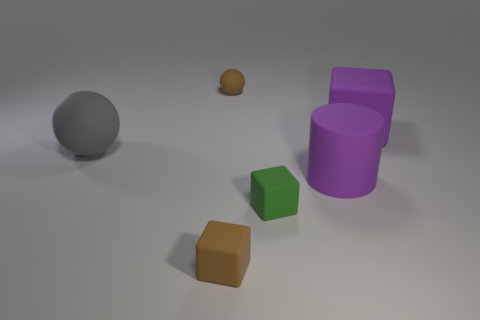What number of metallic objects are either big yellow blocks or brown objects?
Provide a short and direct response. 0. There is a gray thing that is made of the same material as the green block; what shape is it?
Your answer should be very brief. Sphere. What number of cyan metal things are the same shape as the small green matte thing?
Your answer should be compact. 0. Does the small brown rubber thing that is on the right side of the tiny brown matte block have the same shape as the big purple matte object behind the gray matte ball?
Your answer should be very brief. No. What number of objects are either large yellow spheres or big gray matte spheres behind the large cylinder?
Make the answer very short. 1. There is a large object that is the same color as the cylinder; what shape is it?
Provide a short and direct response. Cube. How many other purple cylinders are the same size as the rubber cylinder?
Your answer should be compact. 0. What number of blue objects are large rubber things or matte things?
Your answer should be compact. 0. There is a large purple thing behind the matte thing on the left side of the brown cube; what shape is it?
Give a very brief answer. Cube. The purple rubber object that is the same size as the purple block is what shape?
Your response must be concise. Cylinder. 